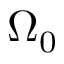<formula> <loc_0><loc_0><loc_500><loc_500>\Omega _ { 0 }</formula> 